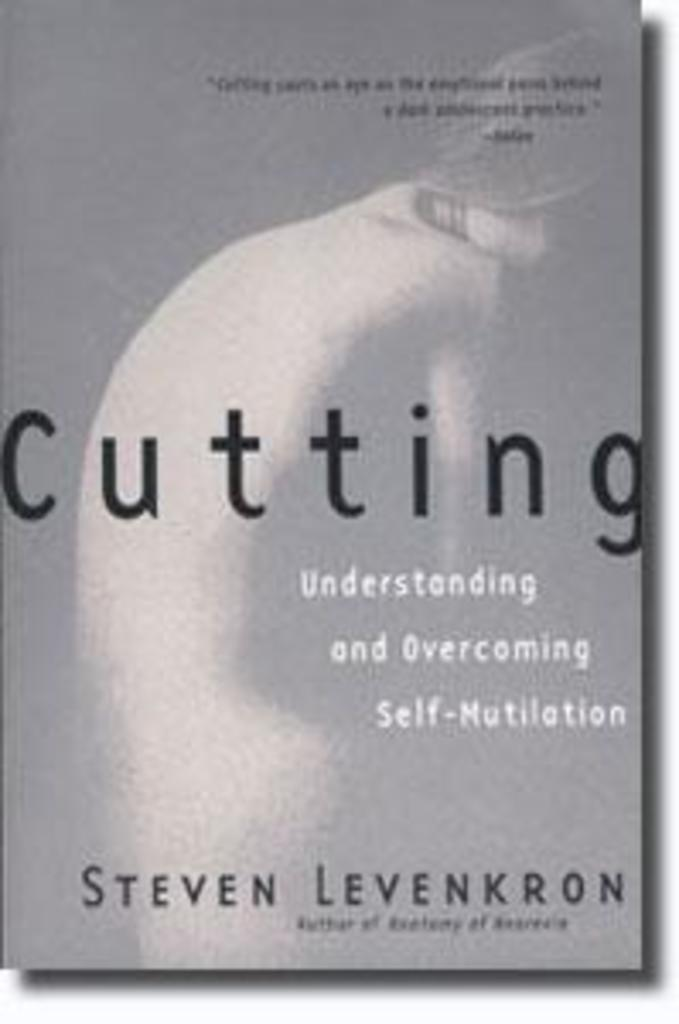<image>
Describe the image concisely. The cover of the book Cutting: Understanding and Overcoming Self-Mutilation 